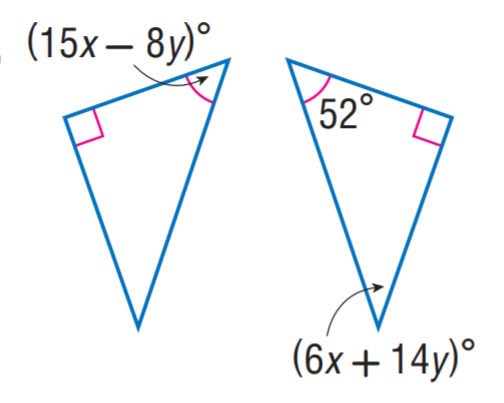Answer the mathemtical geometry problem and directly provide the correct option letter.
Question: Find x.
Choices: A: 1 B: 2 C: 3 D: 4 D 